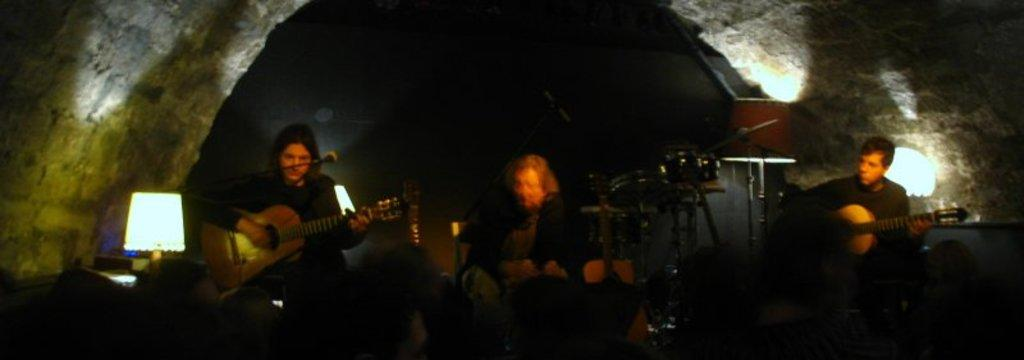How many people are in the image? There are three people in the image. What are the people doing in the image? The people are playing guitar. What object is in front of the people? There is a microphone in front of the people. What type of lighting is visible in the image? There are lamps visible in the image. What can be seen in the background of the image? There is a wall in the image. What type of respect can be seen on the wall in the image? There is no indication of respect or any specific type of respect visible on the wall in the image. 